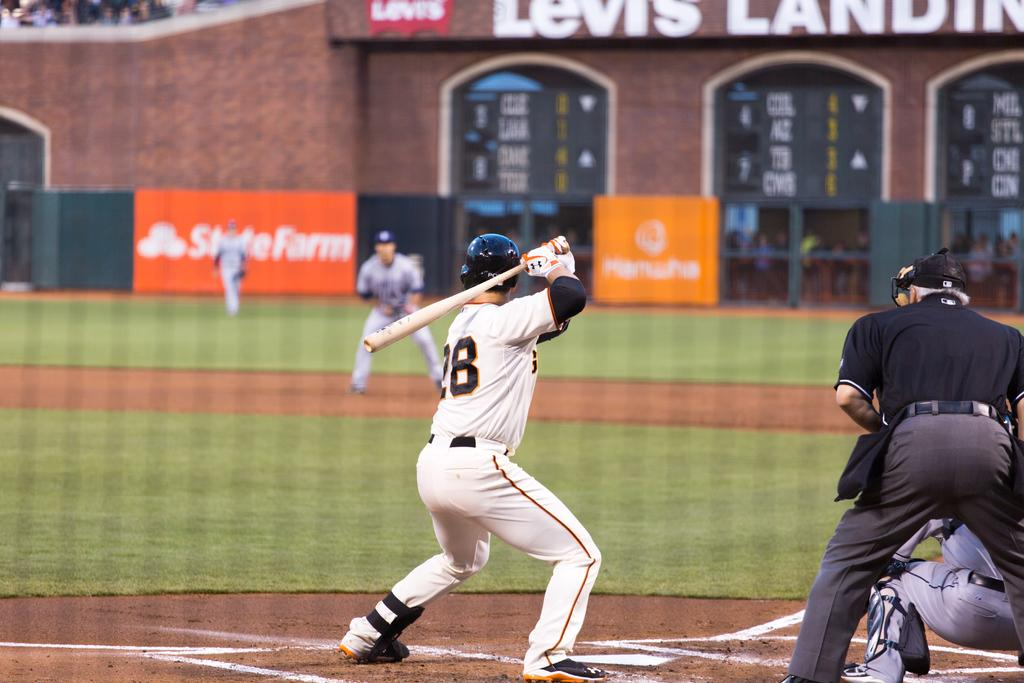Provide a one-sentence caption for the provided image. Player number 28 holds up the baseball bat in preparation for a hit. 